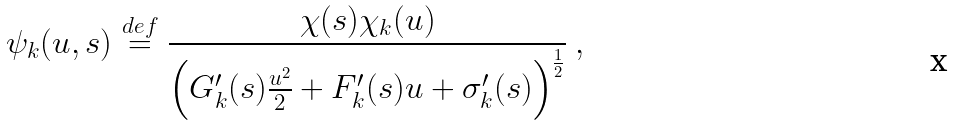Convert formula to latex. <formula><loc_0><loc_0><loc_500><loc_500>\psi _ { k } ( u , s ) \overset { d e f } { = } \frac { \chi ( s ) \chi _ { k } ( u ) } { \left ( G ^ { \prime } _ { k } ( s ) \frac { u ^ { 2 } } { 2 } + F ^ { \prime } _ { k } ( s ) u + \sigma ^ { \prime } _ { k } ( s ) \right ) ^ { \frac { 1 } { 2 } } } \ ,</formula> 